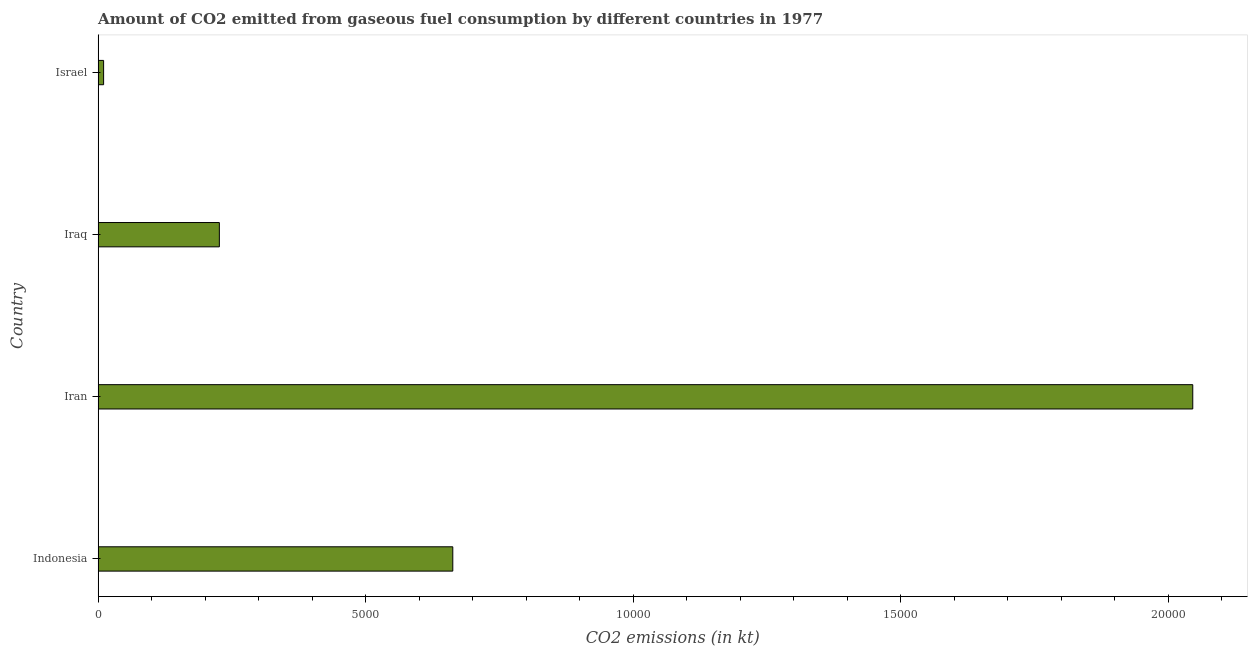Does the graph contain any zero values?
Ensure brevity in your answer.  No. What is the title of the graph?
Your response must be concise. Amount of CO2 emitted from gaseous fuel consumption by different countries in 1977. What is the label or title of the X-axis?
Your response must be concise. CO2 emissions (in kt). What is the co2 emissions from gaseous fuel consumption in Indonesia?
Keep it short and to the point. 6629.94. Across all countries, what is the maximum co2 emissions from gaseous fuel consumption?
Your response must be concise. 2.05e+04. Across all countries, what is the minimum co2 emissions from gaseous fuel consumption?
Keep it short and to the point. 102.68. In which country was the co2 emissions from gaseous fuel consumption maximum?
Give a very brief answer. Iran. In which country was the co2 emissions from gaseous fuel consumption minimum?
Offer a terse response. Israel. What is the sum of the co2 emissions from gaseous fuel consumption?
Your answer should be compact. 2.95e+04. What is the difference between the co2 emissions from gaseous fuel consumption in Iran and Iraq?
Keep it short and to the point. 1.82e+04. What is the average co2 emissions from gaseous fuel consumption per country?
Keep it short and to the point. 7365.17. What is the median co2 emissions from gaseous fuel consumption?
Ensure brevity in your answer.  4448.07. What is the ratio of the co2 emissions from gaseous fuel consumption in Indonesia to that in Israel?
Make the answer very short. 64.57. Is the difference between the co2 emissions from gaseous fuel consumption in Indonesia and Israel greater than the difference between any two countries?
Offer a very short reply. No. What is the difference between the highest and the second highest co2 emissions from gaseous fuel consumption?
Ensure brevity in your answer.  1.38e+04. What is the difference between the highest and the lowest co2 emissions from gaseous fuel consumption?
Keep it short and to the point. 2.04e+04. What is the difference between two consecutive major ticks on the X-axis?
Your answer should be very brief. 5000. Are the values on the major ticks of X-axis written in scientific E-notation?
Offer a terse response. No. What is the CO2 emissions (in kt) in Indonesia?
Your answer should be very brief. 6629.94. What is the CO2 emissions (in kt) in Iran?
Make the answer very short. 2.05e+04. What is the CO2 emissions (in kt) in Iraq?
Give a very brief answer. 2266.21. What is the CO2 emissions (in kt) in Israel?
Keep it short and to the point. 102.68. What is the difference between the CO2 emissions (in kt) in Indonesia and Iran?
Ensure brevity in your answer.  -1.38e+04. What is the difference between the CO2 emissions (in kt) in Indonesia and Iraq?
Offer a terse response. 4363.73. What is the difference between the CO2 emissions (in kt) in Indonesia and Israel?
Keep it short and to the point. 6527.26. What is the difference between the CO2 emissions (in kt) in Iran and Iraq?
Provide a succinct answer. 1.82e+04. What is the difference between the CO2 emissions (in kt) in Iran and Israel?
Your answer should be compact. 2.04e+04. What is the difference between the CO2 emissions (in kt) in Iraq and Israel?
Offer a very short reply. 2163.53. What is the ratio of the CO2 emissions (in kt) in Indonesia to that in Iran?
Provide a succinct answer. 0.32. What is the ratio of the CO2 emissions (in kt) in Indonesia to that in Iraq?
Your answer should be compact. 2.93. What is the ratio of the CO2 emissions (in kt) in Indonesia to that in Israel?
Your answer should be compact. 64.57. What is the ratio of the CO2 emissions (in kt) in Iran to that in Iraq?
Offer a terse response. 9.03. What is the ratio of the CO2 emissions (in kt) in Iran to that in Israel?
Offer a very short reply. 199.29. What is the ratio of the CO2 emissions (in kt) in Iraq to that in Israel?
Provide a short and direct response. 22.07. 